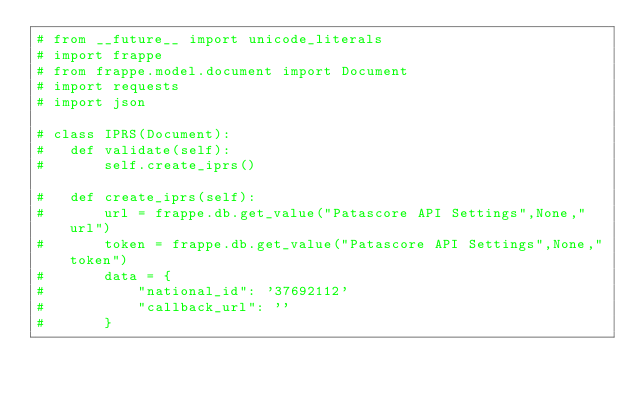<code> <loc_0><loc_0><loc_500><loc_500><_Python_># from __future__ import unicode_literals
# import frappe
# from frappe.model.document import Document
# import requests
# import json

# class IPRS(Document):
# 	def validate(self):
# 		self.create_iprs()

# 	def create_iprs(self):
# 		url = frappe.db.get_value("Patascore API Settings",None,"url")
# 		token = frappe.db.get_value("Patascore API Settings",None,"token")
# 		data = {
# 			"national_id": '37692112'
# 			"callback_url": ''
# 		}</code> 